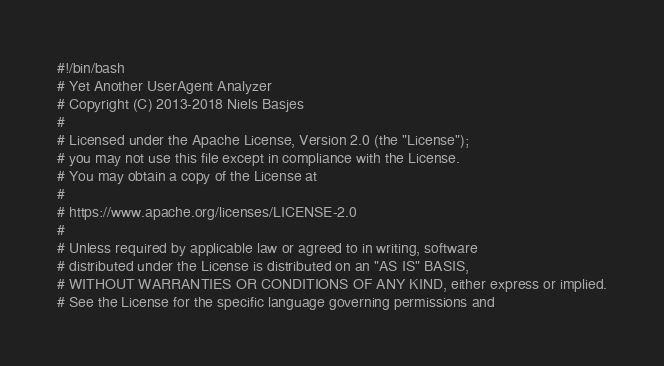Convert code to text. <code><loc_0><loc_0><loc_500><loc_500><_Bash_>#!/bin/bash
# Yet Another UserAgent Analyzer
# Copyright (C) 2013-2018 Niels Basjes
#
# Licensed under the Apache License, Version 2.0 (the "License");
# you may not use this file except in compliance with the License.
# You may obtain a copy of the License at
#
# https://www.apache.org/licenses/LICENSE-2.0
#
# Unless required by applicable law or agreed to in writing, software
# distributed under the License is distributed on an "AS IS" BASIS,
# WITHOUT WARRANTIES OR CONDITIONS OF ANY KIND, either express or implied.
# See the License for the specific language governing permissions and</code> 